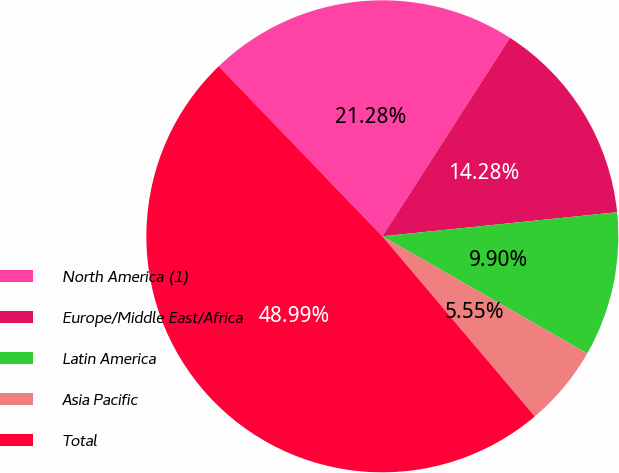<chart> <loc_0><loc_0><loc_500><loc_500><pie_chart><fcel>North America (1)<fcel>Europe/Middle East/Africa<fcel>Latin America<fcel>Asia Pacific<fcel>Total<nl><fcel>21.28%<fcel>14.28%<fcel>9.9%<fcel>5.55%<fcel>48.99%<nl></chart> 